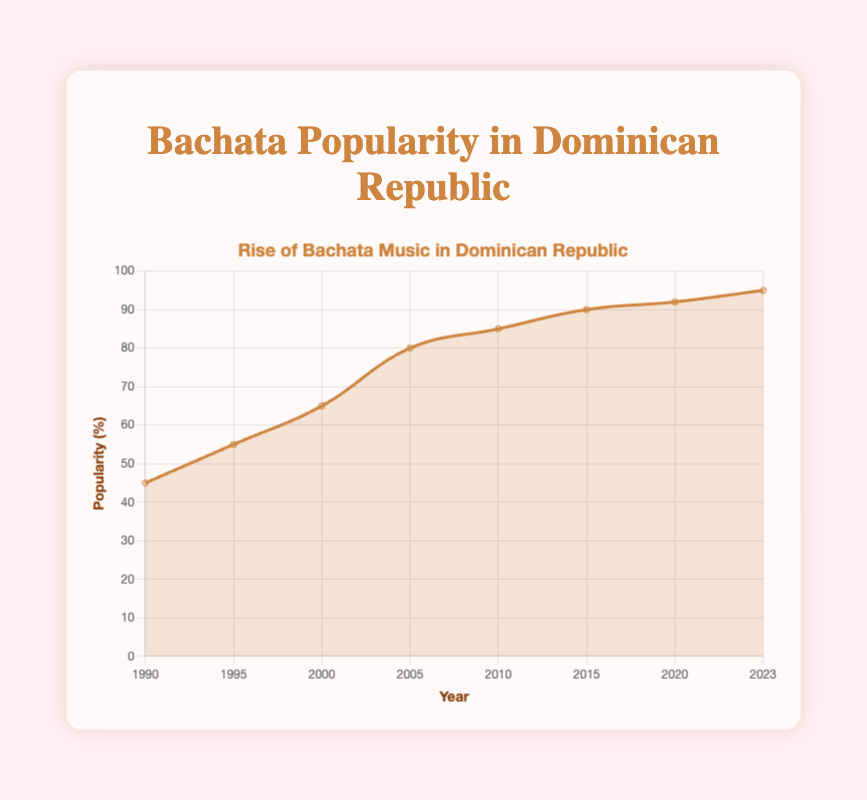What is the title of the chart? The title of the chart, as shown at the top, states what the chart is about.
Answer: "Rise of Bachata Music in Dominican Republic" What is the highest percentage of bachata popularity recorded in the chart? Look for the maximum value on the y-axis and the corresponding data point for it.
Answer: 95% In which year did bachata music's popularity reach 80%? Find the data point where the popularity value on the y-axis reaches 80%.
Answer: 2005 Between which years did bachata music's popularity increase the most? Compare the differences in popularity between consecutive years and identify the largest increase.
Answer: Between 2000 and 2005 How many data points are represented in the chart? Count the number of data points shown in the chart.
Answer: 8 What is the average popularity percentage of bachata music from 1990 to 2023? Sum up all the popularity values and divide by the number of data points: (45 + 55 + 65 + 80 + 85 + 90 + 92 + 95) / 8.
Answer: 75.875 What is the difference in popularity percentage between 1990 and 2023? Subtract the popularity value in 1990 from the value in 2023: 95 - 45.
Answer: 50 During which period did bachata music's popularity increase more: 1995 to 2000 or 2015 to 2020? Calculate the increase in popularity for both periods and compare: 
(65 - 55) for 1995-2000 and 
(92 - 90) for 2015-2020.
Answer: 1995 to 2000 Which year marks the first time bachata music's popularity reached at least 85%? Identify the first year on the x-axis where the popularity value meets or exceeds 85%.
Answer: 2010 